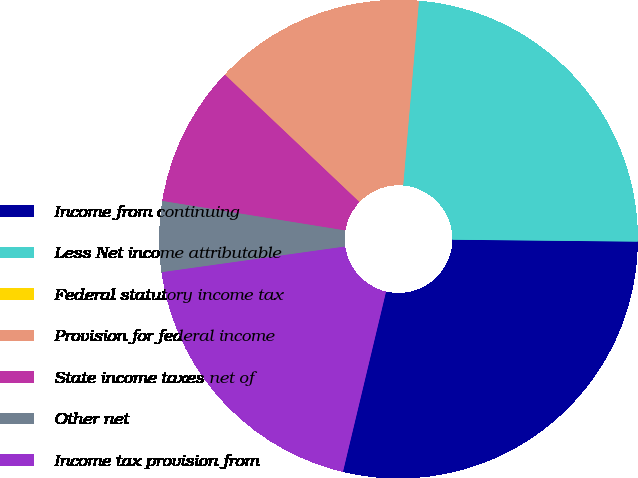<chart> <loc_0><loc_0><loc_500><loc_500><pie_chart><fcel>Income from continuing<fcel>Less Net income attributable<fcel>Federal statutory income tax<fcel>Provision for federal income<fcel>State income taxes net of<fcel>Other net<fcel>Income tax provision from<nl><fcel>28.57%<fcel>23.81%<fcel>0.0%<fcel>14.29%<fcel>9.52%<fcel>4.76%<fcel>19.05%<nl></chart> 